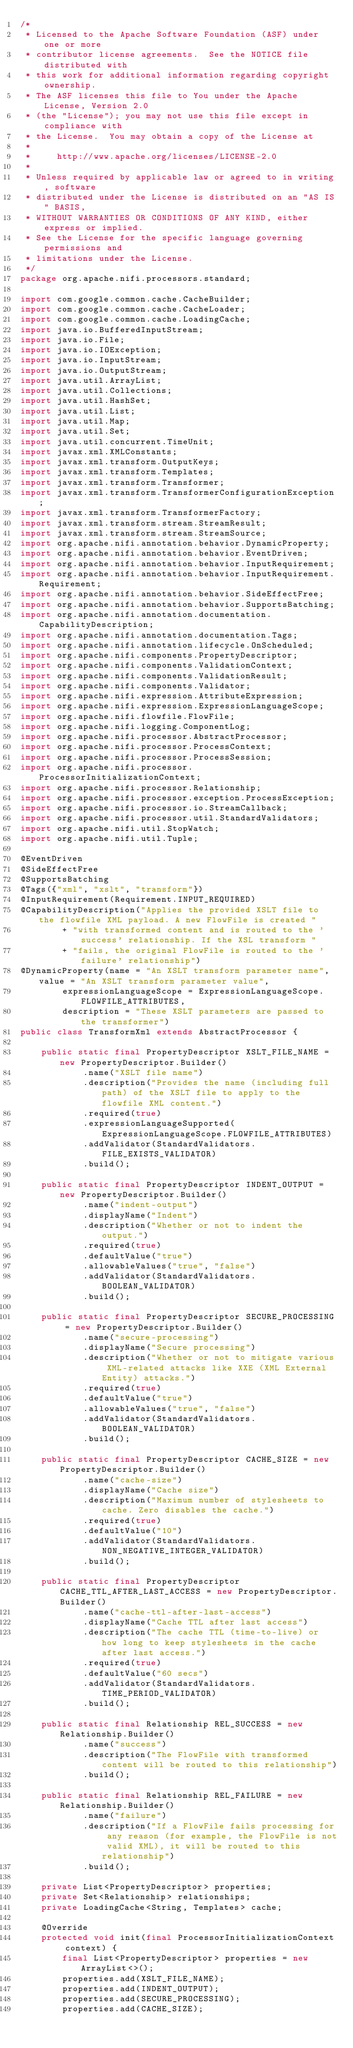<code> <loc_0><loc_0><loc_500><loc_500><_Java_>/*
 * Licensed to the Apache Software Foundation (ASF) under one or more
 * contributor license agreements.  See the NOTICE file distributed with
 * this work for additional information regarding copyright ownership.
 * The ASF licenses this file to You under the Apache License, Version 2.0
 * (the "License"); you may not use this file except in compliance with
 * the License.  You may obtain a copy of the License at
 *
 *     http://www.apache.org/licenses/LICENSE-2.0
 *
 * Unless required by applicable law or agreed to in writing, software
 * distributed under the License is distributed on an "AS IS" BASIS,
 * WITHOUT WARRANTIES OR CONDITIONS OF ANY KIND, either express or implied.
 * See the License for the specific language governing permissions and
 * limitations under the License.
 */
package org.apache.nifi.processors.standard;

import com.google.common.cache.CacheBuilder;
import com.google.common.cache.CacheLoader;
import com.google.common.cache.LoadingCache;
import java.io.BufferedInputStream;
import java.io.File;
import java.io.IOException;
import java.io.InputStream;
import java.io.OutputStream;
import java.util.ArrayList;
import java.util.Collections;
import java.util.HashSet;
import java.util.List;
import java.util.Map;
import java.util.Set;
import java.util.concurrent.TimeUnit;
import javax.xml.XMLConstants;
import javax.xml.transform.OutputKeys;
import javax.xml.transform.Templates;
import javax.xml.transform.Transformer;
import javax.xml.transform.TransformerConfigurationException;
import javax.xml.transform.TransformerFactory;
import javax.xml.transform.stream.StreamResult;
import javax.xml.transform.stream.StreamSource;
import org.apache.nifi.annotation.behavior.DynamicProperty;
import org.apache.nifi.annotation.behavior.EventDriven;
import org.apache.nifi.annotation.behavior.InputRequirement;
import org.apache.nifi.annotation.behavior.InputRequirement.Requirement;
import org.apache.nifi.annotation.behavior.SideEffectFree;
import org.apache.nifi.annotation.behavior.SupportsBatching;
import org.apache.nifi.annotation.documentation.CapabilityDescription;
import org.apache.nifi.annotation.documentation.Tags;
import org.apache.nifi.annotation.lifecycle.OnScheduled;
import org.apache.nifi.components.PropertyDescriptor;
import org.apache.nifi.components.ValidationContext;
import org.apache.nifi.components.ValidationResult;
import org.apache.nifi.components.Validator;
import org.apache.nifi.expression.AttributeExpression;
import org.apache.nifi.expression.ExpressionLanguageScope;
import org.apache.nifi.flowfile.FlowFile;
import org.apache.nifi.logging.ComponentLog;
import org.apache.nifi.processor.AbstractProcessor;
import org.apache.nifi.processor.ProcessContext;
import org.apache.nifi.processor.ProcessSession;
import org.apache.nifi.processor.ProcessorInitializationContext;
import org.apache.nifi.processor.Relationship;
import org.apache.nifi.processor.exception.ProcessException;
import org.apache.nifi.processor.io.StreamCallback;
import org.apache.nifi.processor.util.StandardValidators;
import org.apache.nifi.util.StopWatch;
import org.apache.nifi.util.Tuple;

@EventDriven
@SideEffectFree
@SupportsBatching
@Tags({"xml", "xslt", "transform"})
@InputRequirement(Requirement.INPUT_REQUIRED)
@CapabilityDescription("Applies the provided XSLT file to the flowfile XML payload. A new FlowFile is created "
        + "with transformed content and is routed to the 'success' relationship. If the XSL transform "
        + "fails, the original FlowFile is routed to the 'failure' relationship")
@DynamicProperty(name = "An XSLT transform parameter name", value = "An XSLT transform parameter value",
        expressionLanguageScope = ExpressionLanguageScope.FLOWFILE_ATTRIBUTES,
        description = "These XSLT parameters are passed to the transformer")
public class TransformXml extends AbstractProcessor {

    public static final PropertyDescriptor XSLT_FILE_NAME = new PropertyDescriptor.Builder()
            .name("XSLT file name")
            .description("Provides the name (including full path) of the XSLT file to apply to the flowfile XML content.")
            .required(true)
            .expressionLanguageSupported(ExpressionLanguageScope.FLOWFILE_ATTRIBUTES)
            .addValidator(StandardValidators.FILE_EXISTS_VALIDATOR)
            .build();

    public static final PropertyDescriptor INDENT_OUTPUT = new PropertyDescriptor.Builder()
            .name("indent-output")
            .displayName("Indent")
            .description("Whether or not to indent the output.")
            .required(true)
            .defaultValue("true")
            .allowableValues("true", "false")
            .addValidator(StandardValidators.BOOLEAN_VALIDATOR)
            .build();

    public static final PropertyDescriptor SECURE_PROCESSING = new PropertyDescriptor.Builder()
            .name("secure-processing")
            .displayName("Secure processing")
            .description("Whether or not to mitigate various XML-related attacks like XXE (XML External Entity) attacks.")
            .required(true)
            .defaultValue("true")
            .allowableValues("true", "false")
            .addValidator(StandardValidators.BOOLEAN_VALIDATOR)
            .build();

    public static final PropertyDescriptor CACHE_SIZE = new PropertyDescriptor.Builder()
            .name("cache-size")
            .displayName("Cache size")
            .description("Maximum number of stylesheets to cache. Zero disables the cache.")
            .required(true)
            .defaultValue("10")
            .addValidator(StandardValidators.NON_NEGATIVE_INTEGER_VALIDATOR)
            .build();

    public static final PropertyDescriptor CACHE_TTL_AFTER_LAST_ACCESS = new PropertyDescriptor.Builder()
            .name("cache-ttl-after-last-access")
            .displayName("Cache TTL after last access")
            .description("The cache TTL (time-to-live) or how long to keep stylesheets in the cache after last access.")
            .required(true)
            .defaultValue("60 secs")
            .addValidator(StandardValidators.TIME_PERIOD_VALIDATOR)
            .build();

    public static final Relationship REL_SUCCESS = new Relationship.Builder()
            .name("success")
            .description("The FlowFile with transformed content will be routed to this relationship")
            .build();

    public static final Relationship REL_FAILURE = new Relationship.Builder()
            .name("failure")
            .description("If a FlowFile fails processing for any reason (for example, the FlowFile is not valid XML), it will be routed to this relationship")
            .build();

    private List<PropertyDescriptor> properties;
    private Set<Relationship> relationships;
    private LoadingCache<String, Templates> cache;

    @Override
    protected void init(final ProcessorInitializationContext context) {
        final List<PropertyDescriptor> properties = new ArrayList<>();
        properties.add(XSLT_FILE_NAME);
        properties.add(INDENT_OUTPUT);
        properties.add(SECURE_PROCESSING);
        properties.add(CACHE_SIZE);</code> 